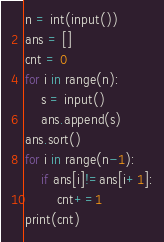<code> <loc_0><loc_0><loc_500><loc_500><_Python_>n = int(input())
ans = []
cnt = 0
for i in range(n):
    s = input()
    ans.append(s)
ans.sort()
for i in range(n-1):
    if ans[i]!=ans[i+1]:
        cnt+=1
print(cnt)</code> 